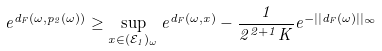Convert formula to latex. <formula><loc_0><loc_0><loc_500><loc_500>e ^ { d _ { F } ( \omega , p _ { 2 } ( \omega ) ) } \geq \sup _ { x \in ( \mathcal { E } _ { 1 } ) _ { \omega } } e ^ { d _ { F } ( \omega , x ) } - \frac { 1 } { 2 ^ { 2 + 1 } K } e ^ { - | | d _ { F } ( \omega ) | | _ { \infty } }</formula> 